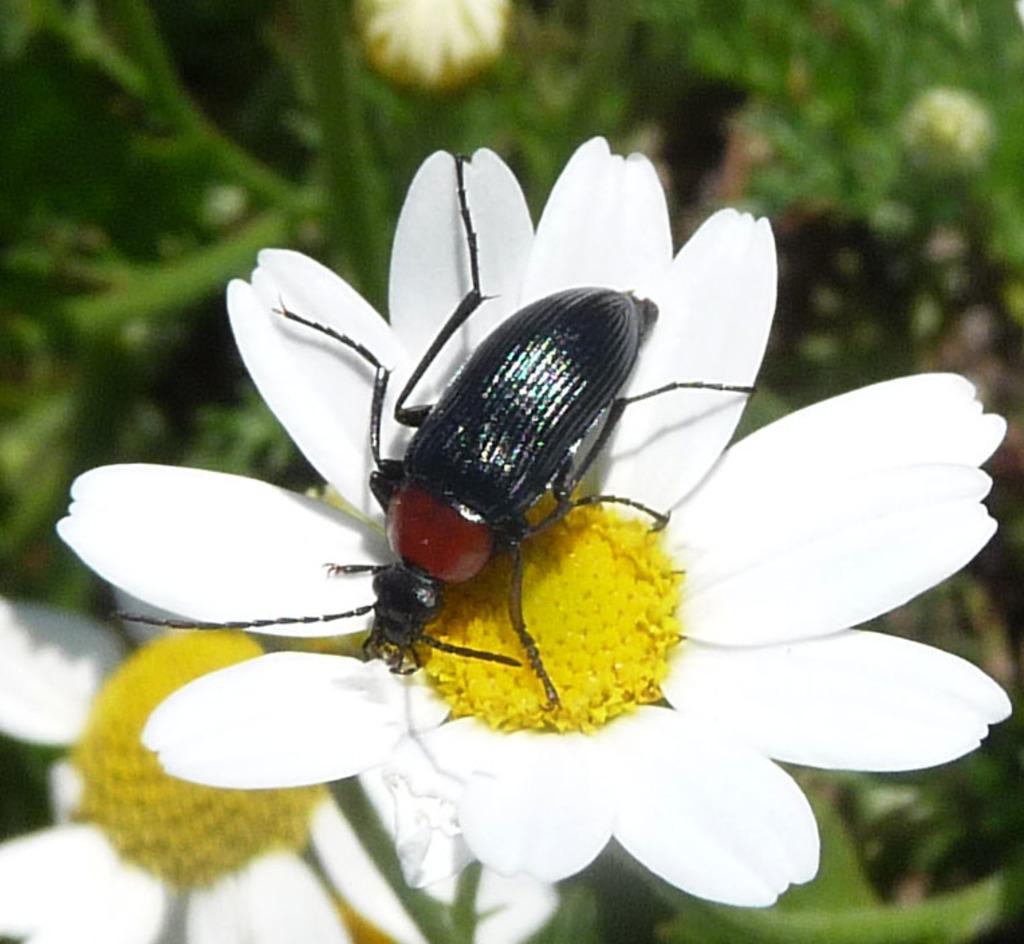In one or two sentences, can you explain what this image depicts? In this picture we can see an insect on the flower. Behind the flower, there is a blurred background. In the bottom left corner of the image, there is another flower. 